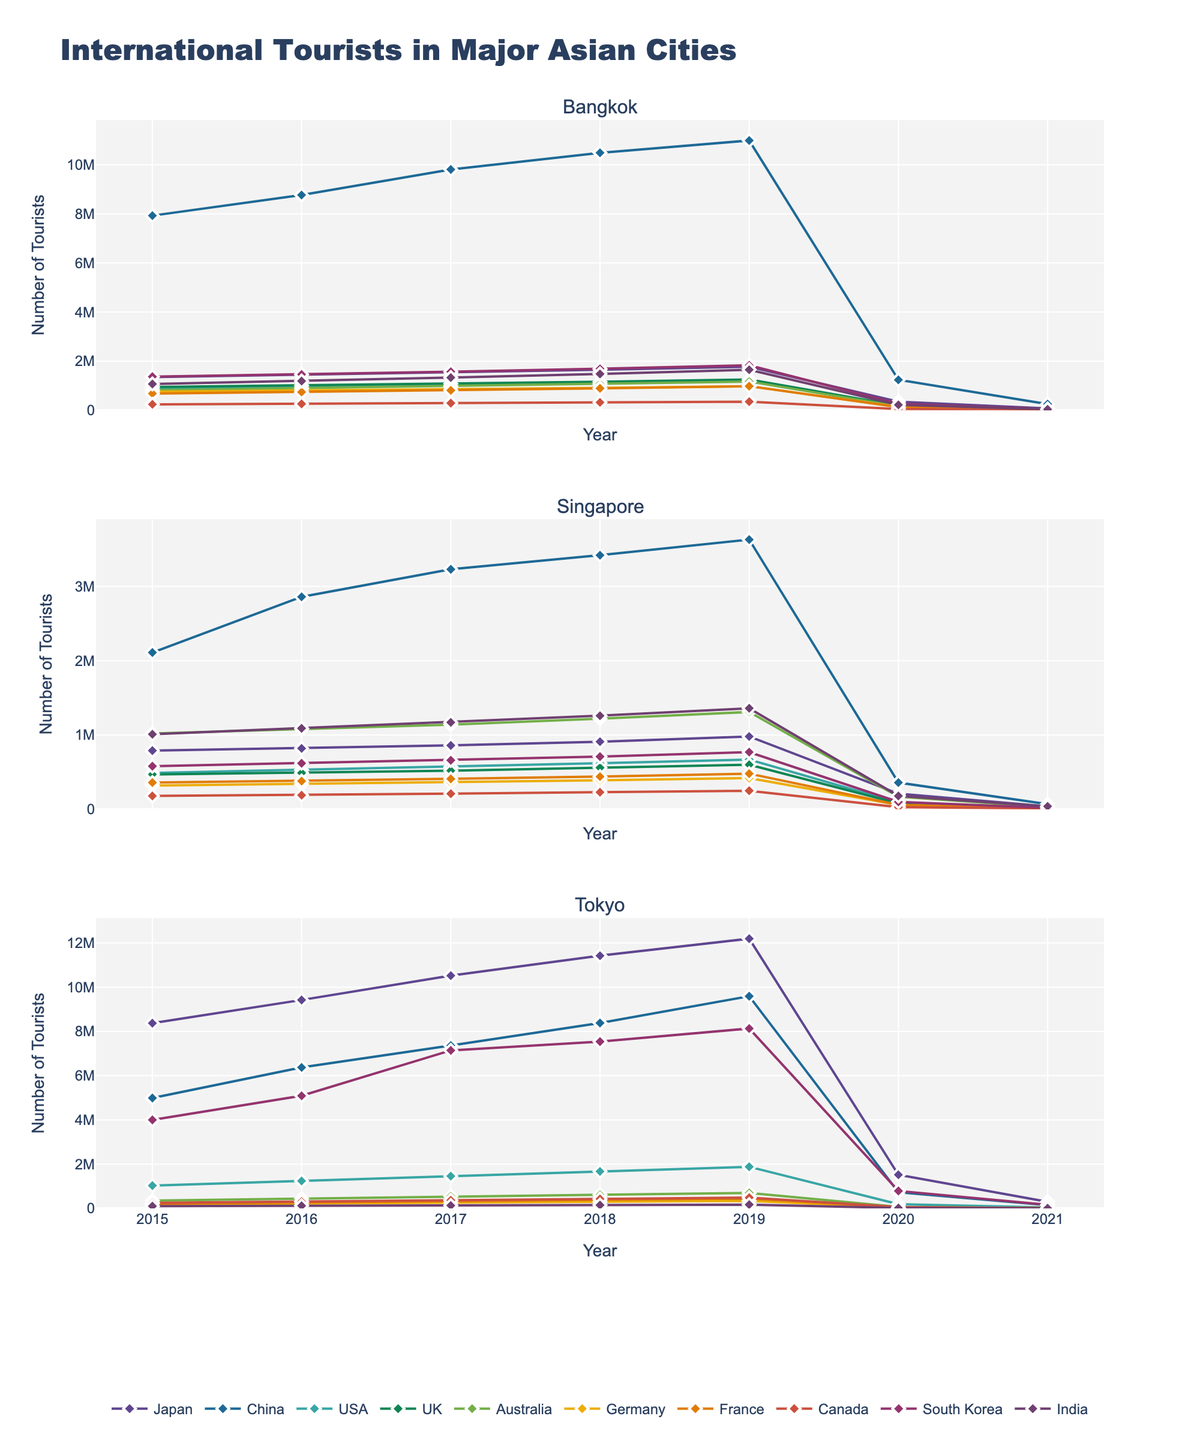What is the trend in the number of tourists from China visiting Bangkok from 2015 to 2021? The number of Chinese tourists visiting Bangkok shows a steady increase from 2015 (7,930,000) to 2019 (10,990,000). There is a sharp decline in 2020 (1,240,000) and further to 250,000 in 2021. The trend is upward initially and then sharply downward.
Answer: Upward until 2019, then sharply downward Between Singapore and Tokyo, which city saw more American tourists in 2019? Comparing the data from 2019, Singapore had 670,000 tourists from the USA, whereas Tokyo had 1,880,000. Therefore, Tokyo saw more American tourists than Singapore in 2019.
Answer: Tokyo Which city experienced the largest drop in tourists from Japan between 2019 and 2020? In 2019, Bangkok had 1,770,000, Singapore had 980,000, and Tokyo had 12,190,000 tourists from Japan. In 2020, these numbers dropped to 350,000 for Bangkok, 210,000 for Singapore, and 1,520,000 for Tokyo. Therefore, Tokyo experienced the largest drop of 10,670,000 tourists (from 12,190,000 to 1,520,000).
Answer: Tokyo How did the number of tourists from South Korea to Tokyo change from 2015 to 2021? In 2015, Tokyo had 4,000,000 tourists from South Korea. This number increased to 8,130,000 by 2019, before dropping significantly to 790,000 in 2020 and 160,000 in 2021. The number rose initially but fell sharply from 2019 to 2021.
Answer: Rose initially, fell sharply from 2019 to 2021 What was the average number of Indian tourists visiting Singapore from 2015 to 2019? To calculate the average, sum the number of Indian tourists visiting Singapore from 2015 (1,010,000) to 2019 (1,360,000) and divide by the number of years (5). (1,010,000 + 1,090,000 + 1,170,000 + 1,260,000 + 1,360,000) = 5,890,000 / 5 = 1,178,000.
Answer: 1,178,000 Which city saw a consistent increase in tourists from Australia from 2015 to 2019? Comparing each city's data: Bangkok increased from 820,000 in 2015 to 1,170,000 in 2019; Singapore from 1,020,000 in 2015 to 1,310,000 in 2019; Tokyo from 350,000 in 2015 to 700,000 in 2019. All three cities saw increases, but all had consistent increases each year.
Answer: Bangkok, Singapore, Tokyo What is the difference in the number of tourists from Germany visiting Singapore and Tokyo in 2016? In 2016, Singapore had 340,000 tourists from Germany, while Tokyo had 220,000. The difference is 340,000 - 220,000 = 120,000.
Answer: 120,000 Which year saw the highest number of tourists from Canada to Bangkok? Looking at the data, the numbers for Canadian tourists to Bangkok each year are: 2015 (240,000), 2016 (260,000), 2017 (290,000), 2018 (320,000), 2019 (350,000), 2020 (50,000), 2021 (10,000). The highest number was in 2019.
Answer: 2019 What is the average number of French tourists visiting Tokyo from 2015 to 2019? Summing the number of French tourists visiting Tokyo from 2015 (210,000), 2016 (270,000), 2017 (330,000), 2018 (390,000), and 2019 (450,000) gives 1,650,000. The average over 5 years is 1,650,000 / 5 = 330,000.
Answer: 330,000 